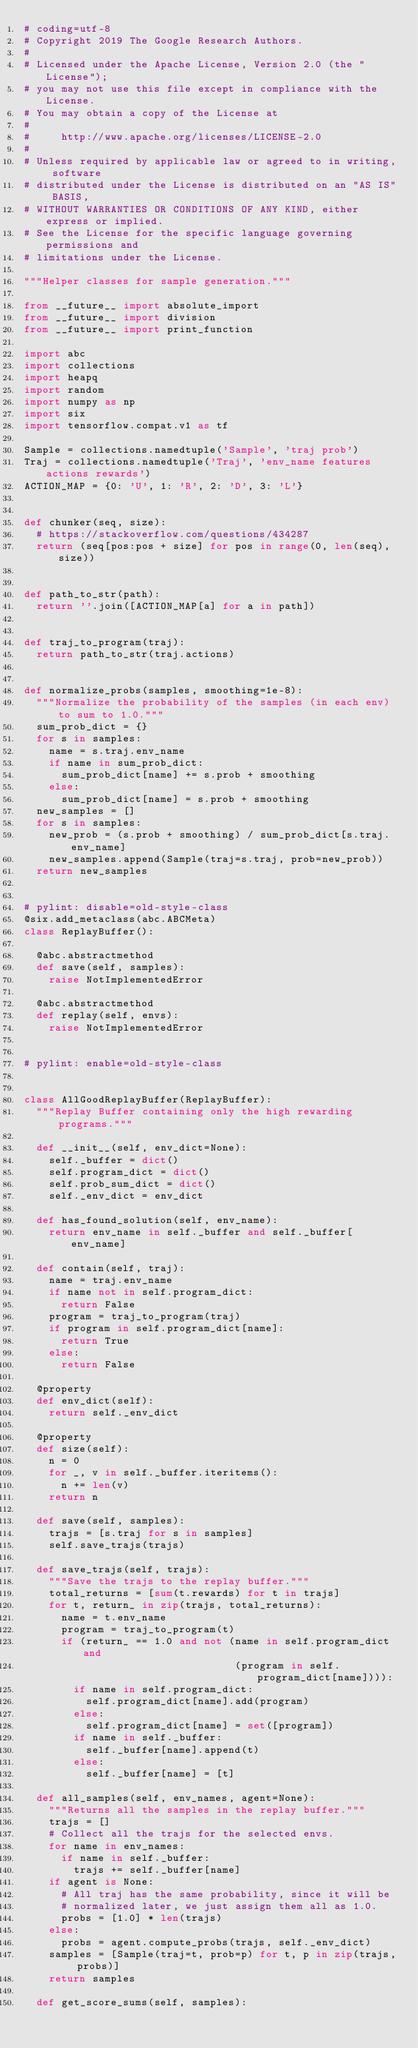Convert code to text. <code><loc_0><loc_0><loc_500><loc_500><_Python_># coding=utf-8
# Copyright 2019 The Google Research Authors.
#
# Licensed under the Apache License, Version 2.0 (the "License");
# you may not use this file except in compliance with the License.
# You may obtain a copy of the License at
#
#     http://www.apache.org/licenses/LICENSE-2.0
#
# Unless required by applicable law or agreed to in writing, software
# distributed under the License is distributed on an "AS IS" BASIS,
# WITHOUT WARRANTIES OR CONDITIONS OF ANY KIND, either express or implied.
# See the License for the specific language governing permissions and
# limitations under the License.

"""Helper classes for sample generation."""

from __future__ import absolute_import
from __future__ import division
from __future__ import print_function

import abc
import collections
import heapq
import random
import numpy as np
import six
import tensorflow.compat.v1 as tf

Sample = collections.namedtuple('Sample', 'traj prob')
Traj = collections.namedtuple('Traj', 'env_name features actions rewards')
ACTION_MAP = {0: 'U', 1: 'R', 2: 'D', 3: 'L'}


def chunker(seq, size):
  # https://stackoverflow.com/questions/434287
  return (seq[pos:pos + size] for pos in range(0, len(seq), size))


def path_to_str(path):
  return ''.join([ACTION_MAP[a] for a in path])


def traj_to_program(traj):
  return path_to_str(traj.actions)


def normalize_probs(samples, smoothing=1e-8):
  """Normalize the probability of the samples (in each env) to sum to 1.0."""
  sum_prob_dict = {}
  for s in samples:
    name = s.traj.env_name
    if name in sum_prob_dict:
      sum_prob_dict[name] += s.prob + smoothing
    else:
      sum_prob_dict[name] = s.prob + smoothing
  new_samples = []
  for s in samples:
    new_prob = (s.prob + smoothing) / sum_prob_dict[s.traj.env_name]
    new_samples.append(Sample(traj=s.traj, prob=new_prob))
  return new_samples


# pylint: disable=old-style-class
@six.add_metaclass(abc.ABCMeta)
class ReplayBuffer():

  @abc.abstractmethod
  def save(self, samples):
    raise NotImplementedError

  @abc.abstractmethod
  def replay(self, envs):
    raise NotImplementedError


# pylint: enable=old-style-class


class AllGoodReplayBuffer(ReplayBuffer):
  """Replay Buffer containing only the high rewarding programs."""

  def __init__(self, env_dict=None):
    self._buffer = dict()
    self.program_dict = dict()
    self.prob_sum_dict = dict()
    self._env_dict = env_dict

  def has_found_solution(self, env_name):
    return env_name in self._buffer and self._buffer[env_name]

  def contain(self, traj):
    name = traj.env_name
    if name not in self.program_dict:
      return False
    program = traj_to_program(traj)
    if program in self.program_dict[name]:
      return True
    else:
      return False

  @property
  def env_dict(self):
    return self._env_dict

  @property
  def size(self):
    n = 0
    for _, v in self._buffer.iteritems():
      n += len(v)
    return n

  def save(self, samples):
    trajs = [s.traj for s in samples]
    self.save_trajs(trajs)

  def save_trajs(self, trajs):
    """Save the trajs to the replay buffer."""
    total_returns = [sum(t.rewards) for t in trajs]
    for t, return_ in zip(trajs, total_returns):
      name = t.env_name
      program = traj_to_program(t)
      if (return_ == 1.0 and not (name in self.program_dict and
                                  (program in self.program_dict[name]))):
        if name in self.program_dict:
          self.program_dict[name].add(program)
        else:
          self.program_dict[name] = set([program])
        if name in self._buffer:
          self._buffer[name].append(t)
        else:
          self._buffer[name] = [t]

  def all_samples(self, env_names, agent=None):
    """Returns all the samples in the replay buffer."""
    trajs = []
    # Collect all the trajs for the selected envs.
    for name in env_names:
      if name in self._buffer:
        trajs += self._buffer[name]
    if agent is None:
      # All traj has the same probability, since it will be
      # normalized later, we just assign them all as 1.0.
      probs = [1.0] * len(trajs)
    else:
      probs = agent.compute_probs(trajs, self._env_dict)
    samples = [Sample(traj=t, prob=p) for t, p in zip(trajs, probs)]
    return samples

  def get_score_sums(self, samples):</code> 